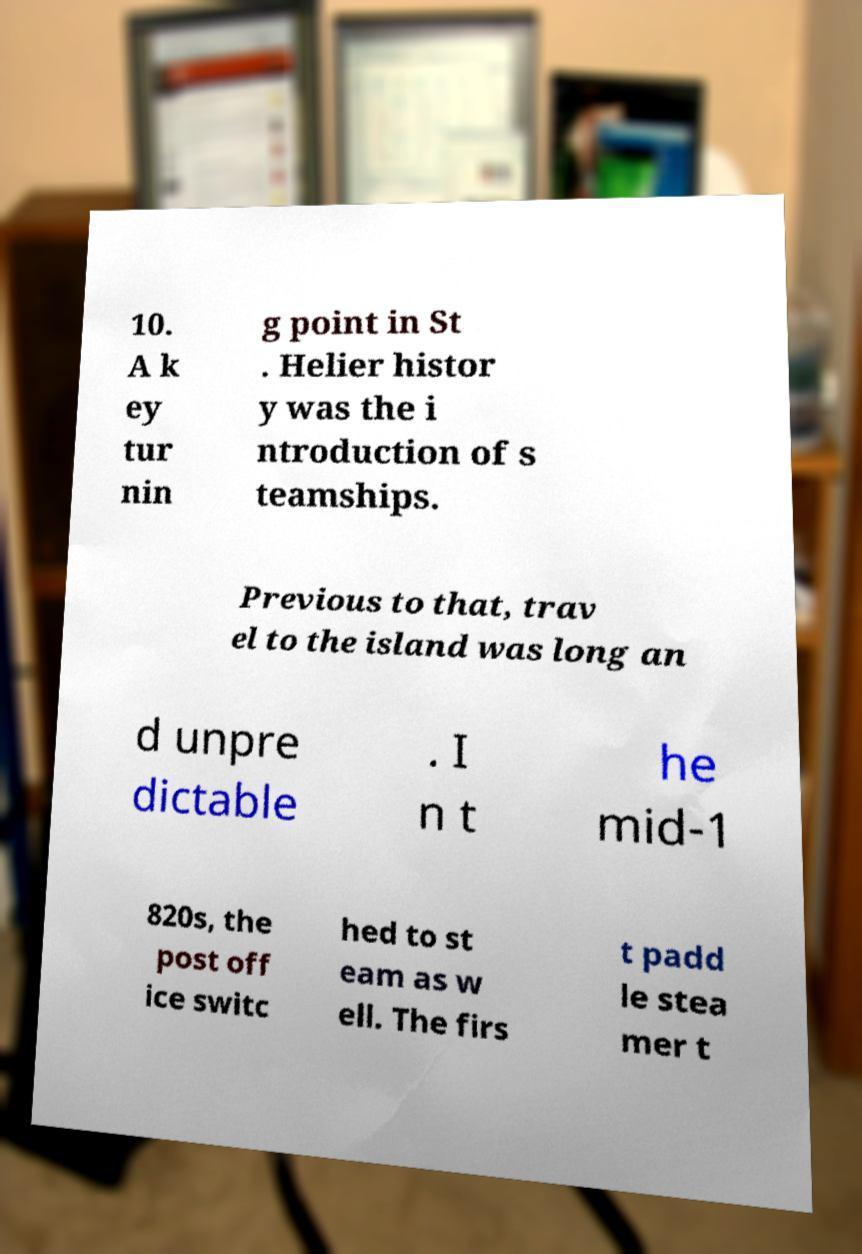Can you accurately transcribe the text from the provided image for me? 10. A k ey tur nin g point in St . Helier histor y was the i ntroduction of s teamships. Previous to that, trav el to the island was long an d unpre dictable . I n t he mid-1 820s, the post off ice switc hed to st eam as w ell. The firs t padd le stea mer t 